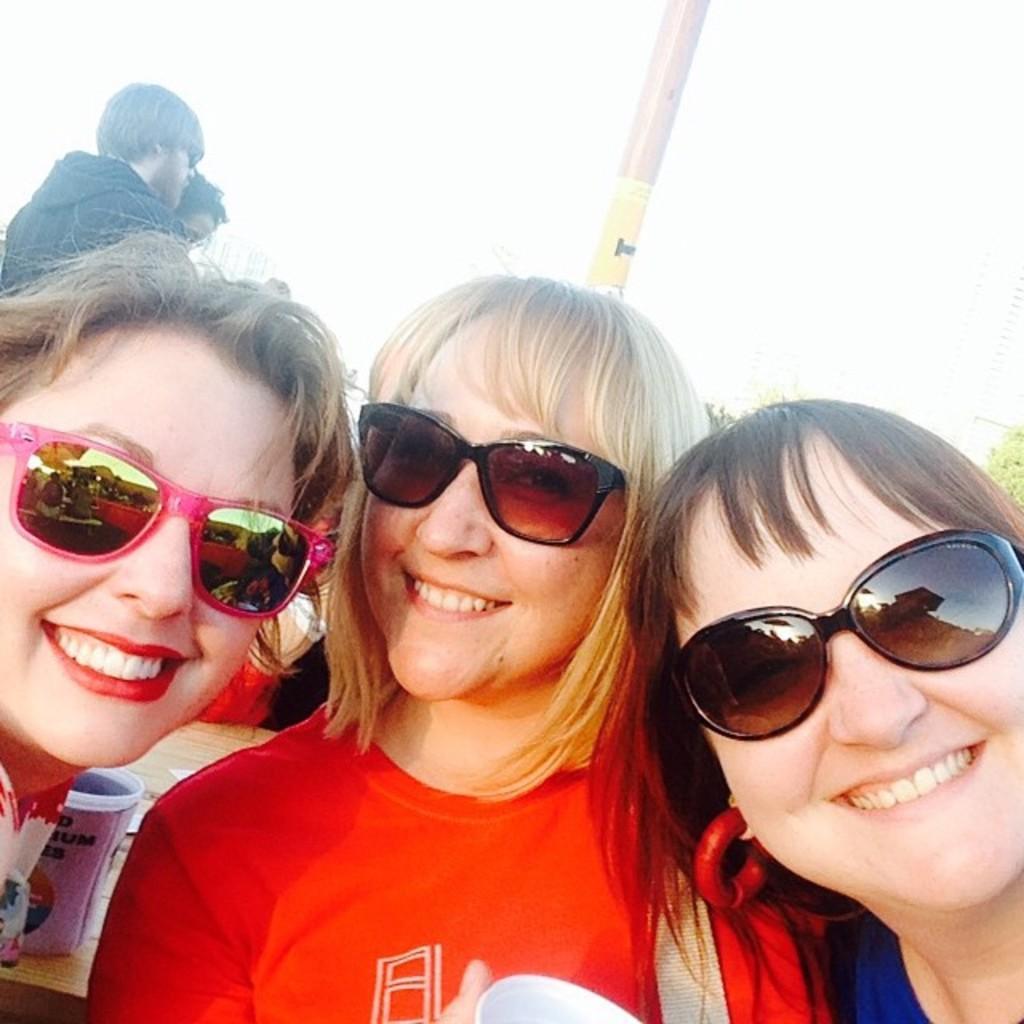In one or two sentences, can you explain what this image depicts? In the foreground of the picture there are three women, behind them there are people and pole. In the background there are trees. Sky is sunny. On the left there is a cup. 